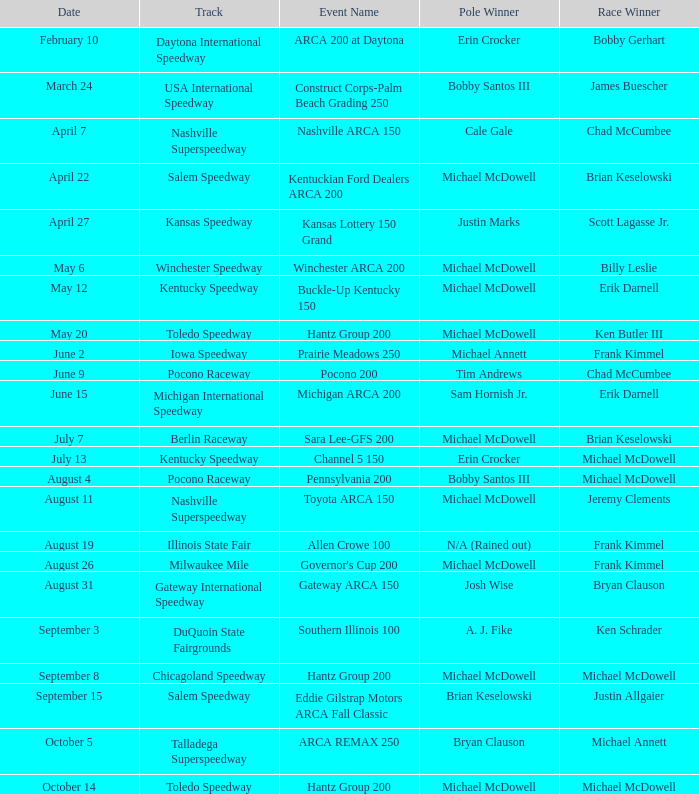What is the track for june 9? Pocono Raceway. 